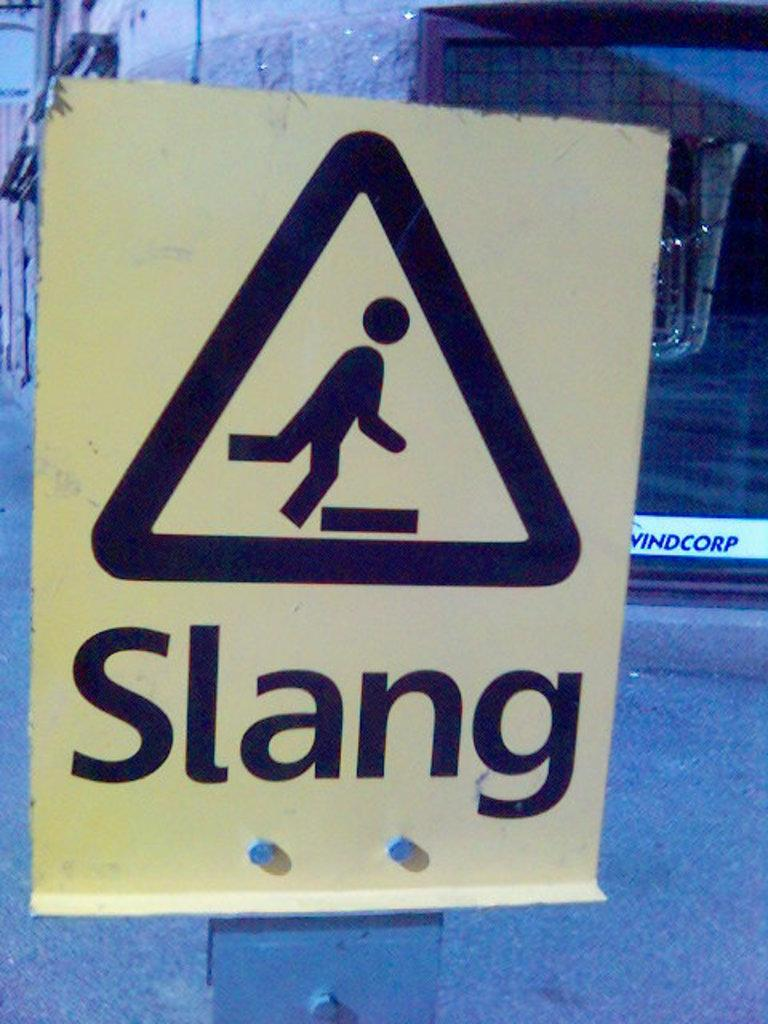What is located in the foreground of the picture? There is a sign board in the foreground of the picture. What can be seen in the background of the picture? There are buildings in the background of the picture. What is at the bottom of the picture? There is a road at the bottom of the picture. What type of nut can be seen growing on the sign board in the image? There are no nuts present on the sign board in the image. How much zinc is visible on the buildings in the background? There is no mention of zinc or any specific materials used in the construction of the buildings in the image. 